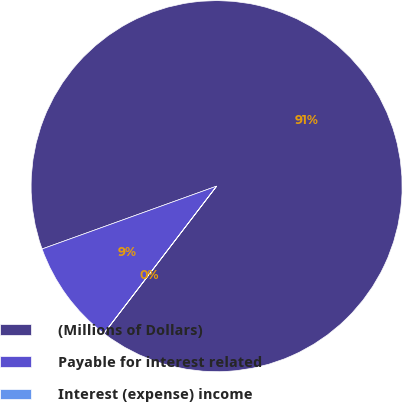Convert chart to OTSL. <chart><loc_0><loc_0><loc_500><loc_500><pie_chart><fcel>(Millions of Dollars)<fcel>Payable for interest related<fcel>Interest (expense) income<nl><fcel>90.89%<fcel>9.1%<fcel>0.01%<nl></chart> 